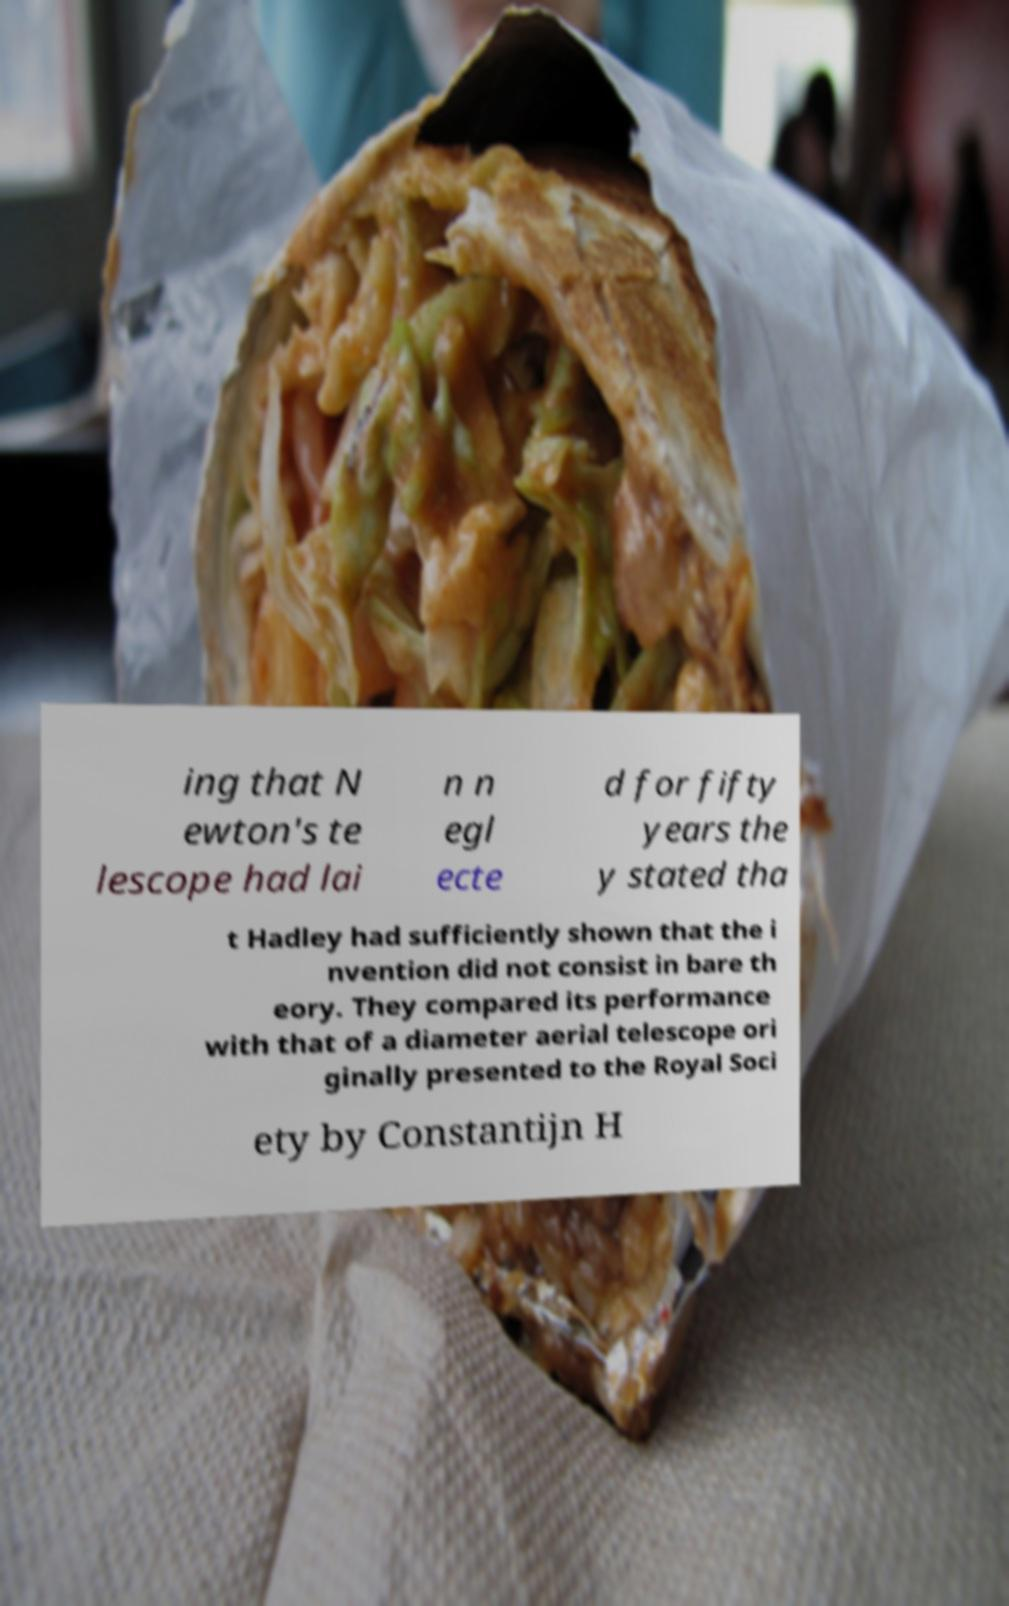Could you extract and type out the text from this image? ing that N ewton's te lescope had lai n n egl ecte d for fifty years the y stated tha t Hadley had sufficiently shown that the i nvention did not consist in bare th eory. They compared its performance with that of a diameter aerial telescope ori ginally presented to the Royal Soci ety by Constantijn H 